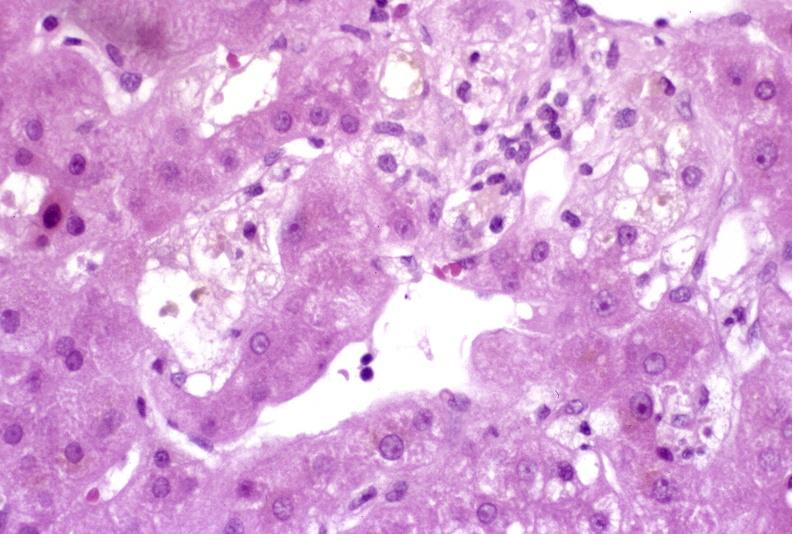s hepatobiliary present?
Answer the question using a single word or phrase. Yes 